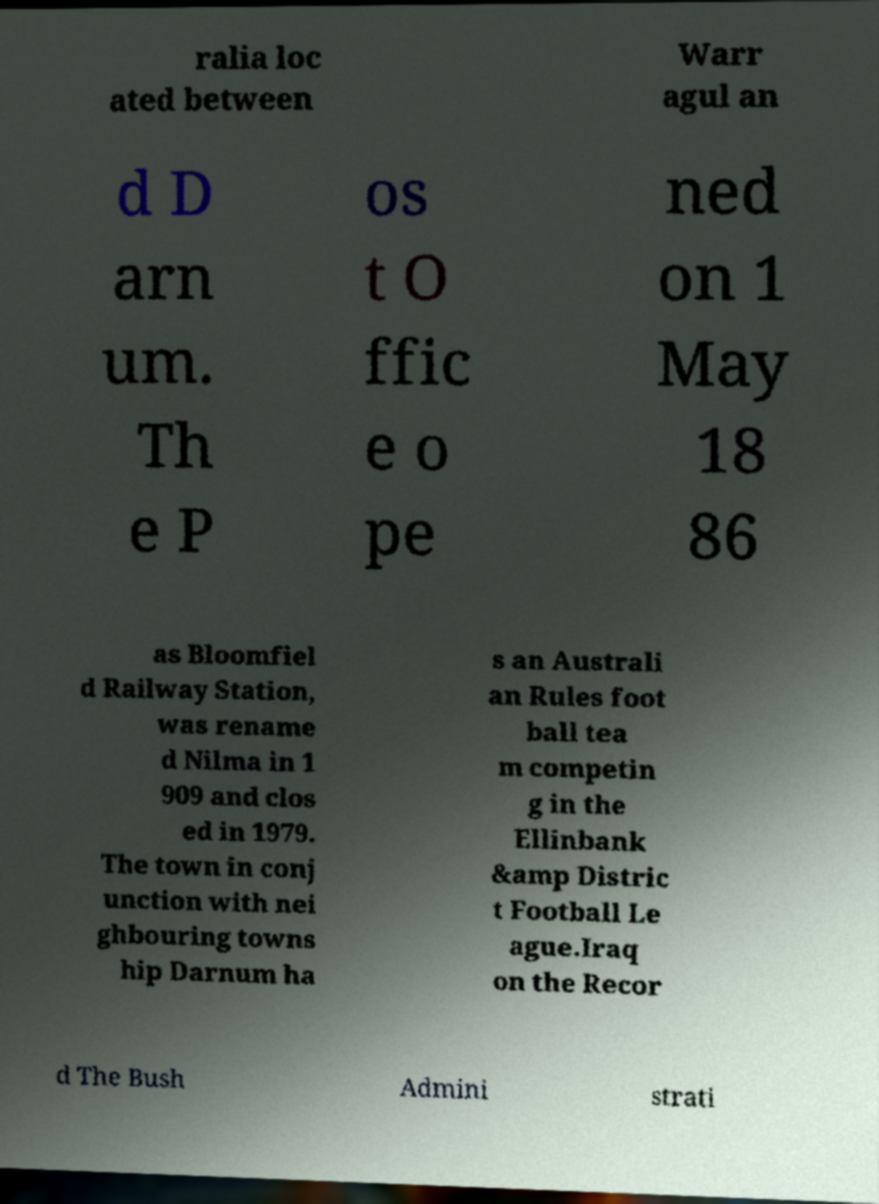Can you read and provide the text displayed in the image?This photo seems to have some interesting text. Can you extract and type it out for me? ralia loc ated between Warr agul an d D arn um. Th e P os t O ffic e o pe ned on 1 May 18 86 as Bloomfiel d Railway Station, was rename d Nilma in 1 909 and clos ed in 1979. The town in conj unction with nei ghbouring towns hip Darnum ha s an Australi an Rules foot ball tea m competin g in the Ellinbank &amp Distric t Football Le ague.Iraq on the Recor d The Bush Admini strati 